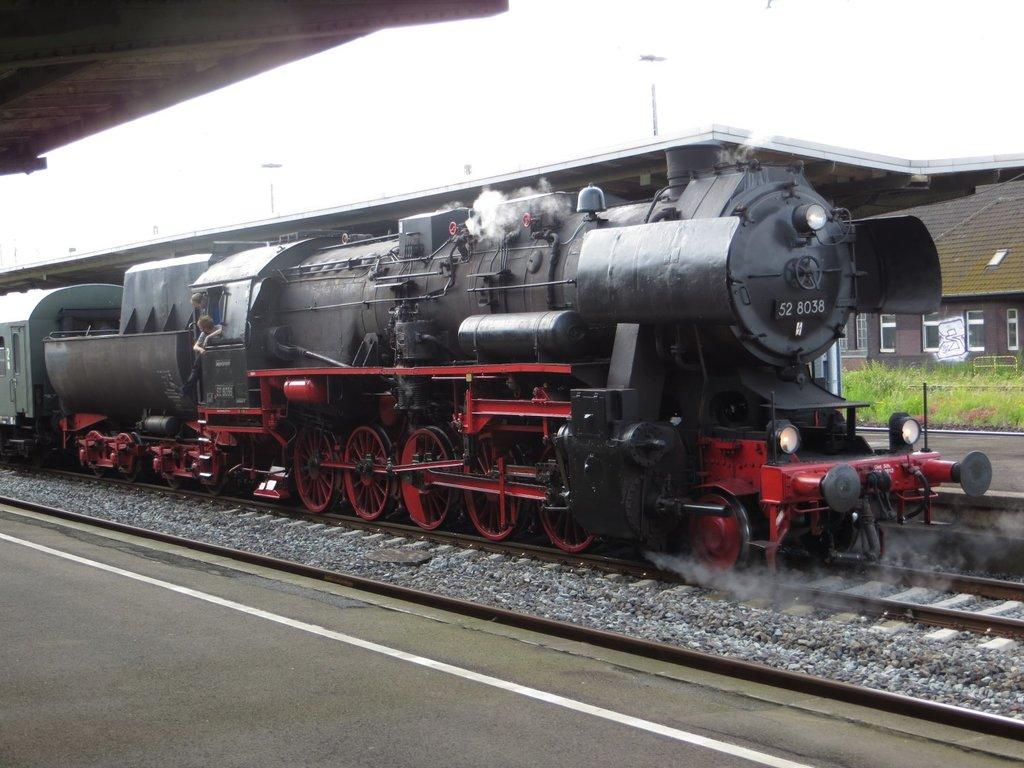What type of vehicle is in the image? There is a steam engine in the image. What is the steam engine situated on? Railway tracks are present in the image. What type of building can be seen in the image? There is a house in the image. What type of vegetation is visible in the image? Grass is visible in the image. What type of face can be seen on the flag in the image? There is no flag present in the image, so it is not possible to determine if there is a face on it. 